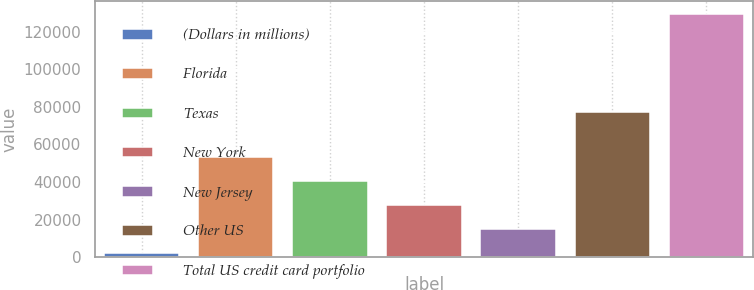Convert chart to OTSL. <chart><loc_0><loc_0><loc_500><loc_500><bar_chart><fcel>(Dollars in millions)<fcel>Florida<fcel>Texas<fcel>New York<fcel>New Jersey<fcel>Other US<fcel>Total US credit card portfolio<nl><fcel>2009<fcel>53062.2<fcel>40298.9<fcel>27535.6<fcel>14772.3<fcel>77076<fcel>129642<nl></chart> 